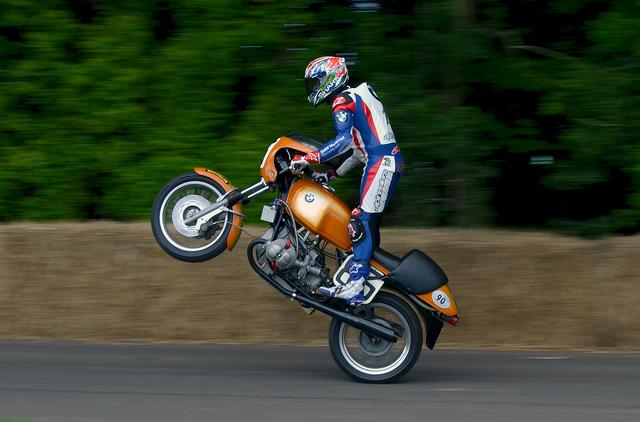Is the person sitting or standing?
Quick response, please. Standing. Is the photo blurry?
Short answer required. Yes. Is this a daredevil?
Concise answer only. Yes. Is the biker moving?
Quick response, please. Yes. What colors are his uniform?
Answer briefly. Red white blue. How many tires are on the ground?
Answer briefly. 1. What color outfit is the rider wearing?
Be succinct. Red, white and blue. IS the man standing?
Give a very brief answer. Yes. 